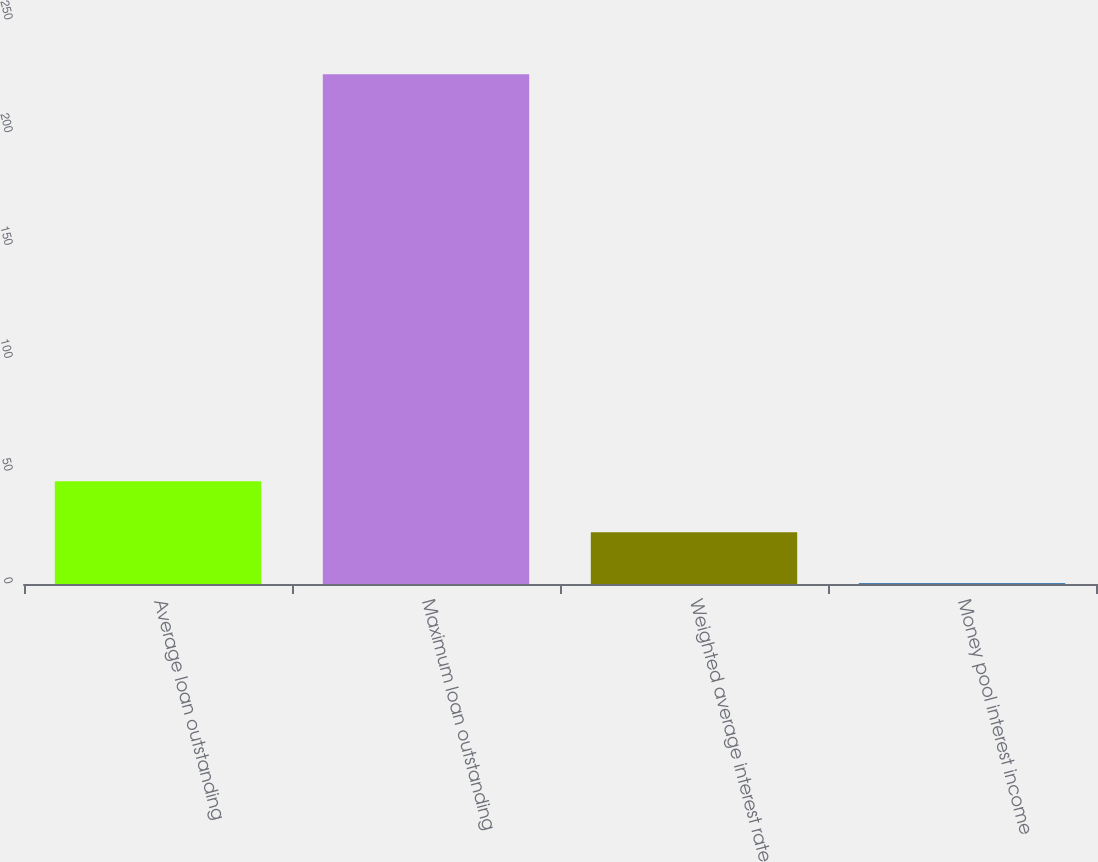Convert chart to OTSL. <chart><loc_0><loc_0><loc_500><loc_500><bar_chart><fcel>Average loan outstanding<fcel>Maximum loan outstanding<fcel>Weighted average interest rate<fcel>Money pool interest income<nl><fcel>45.52<fcel>226<fcel>22.96<fcel>0.4<nl></chart> 